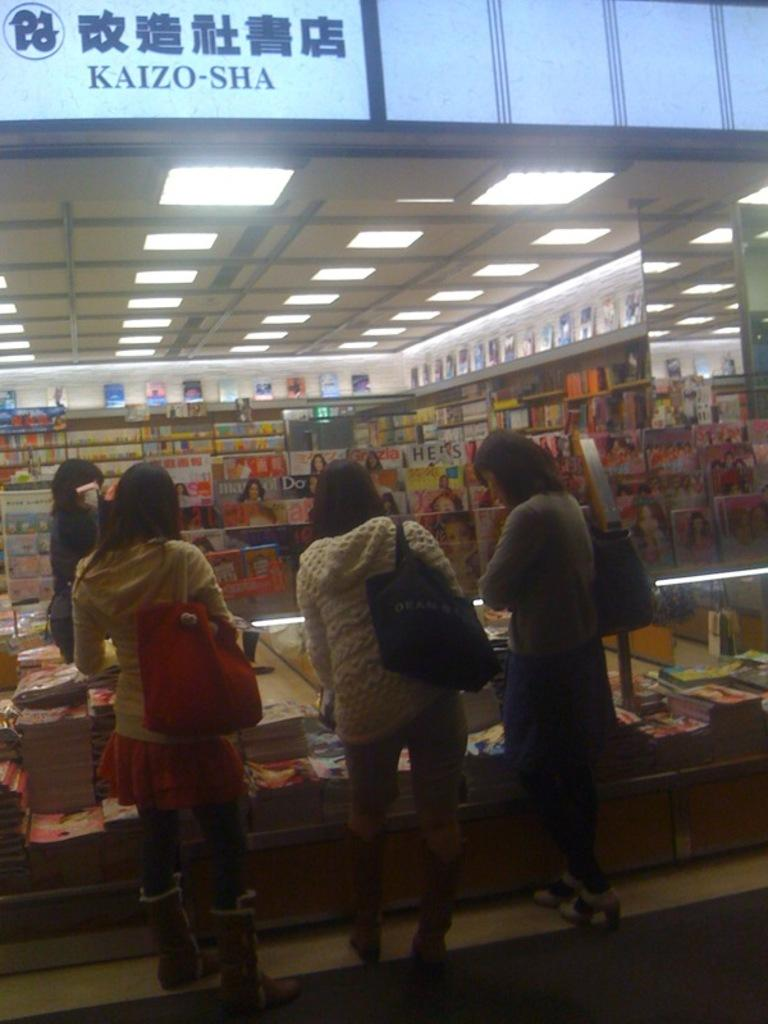Provide a one-sentence caption for the provided image. Three women are browsing magazines at the Kaizo-Sha bookstore. 